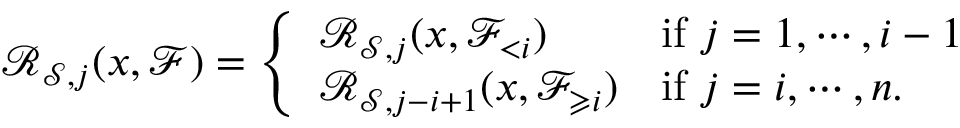<formula> <loc_0><loc_0><loc_500><loc_500>{ \mathcal { R } } _ { { \mathcal { S } } , j } ( x , \ m a t h s c r { F } ) = \left \{ \begin{array} { l l } { { \mathcal { R } } _ { { \mathcal { S } } , j } ( x , \ m a t h s c r { F } _ { < i } ) } & { i f j = 1 , \cdots , i - 1 } \\ { { \mathcal { R } } _ { { \mathcal { S } } , j - i + 1 } ( x , \ m a t h s c r { F } _ { \geqslant i } ) } & { i f j = i , \cdots , n . } \end{array}</formula> 